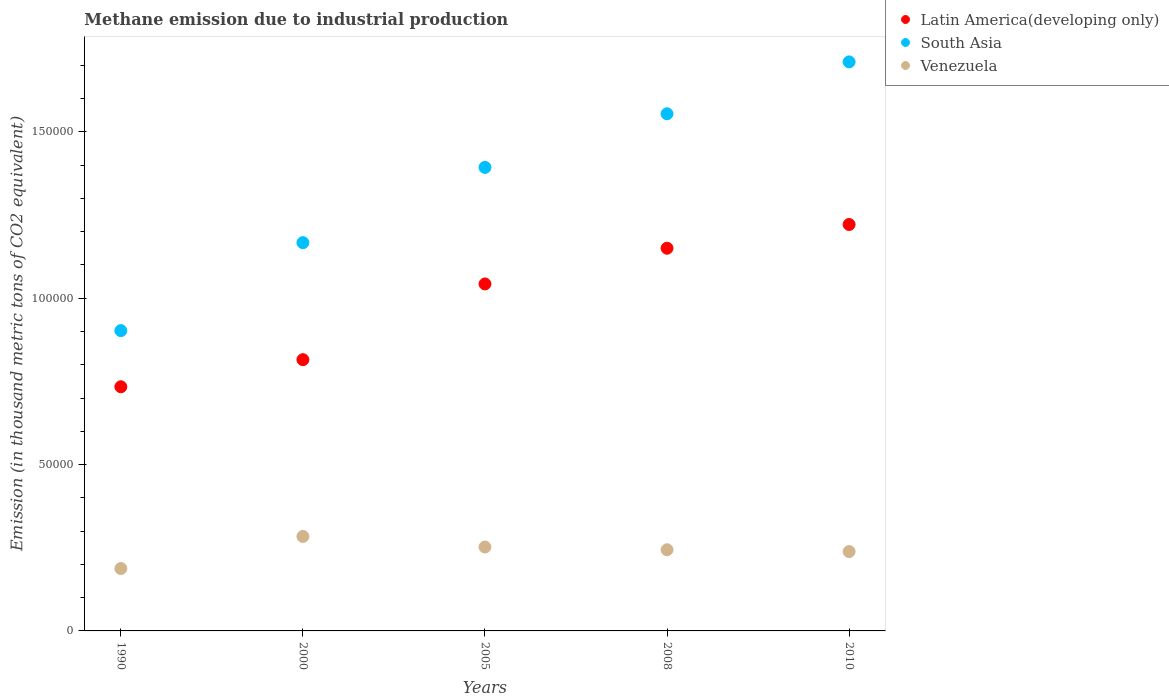How many different coloured dotlines are there?
Your answer should be very brief. 3. Is the number of dotlines equal to the number of legend labels?
Make the answer very short. Yes. What is the amount of methane emitted in Latin America(developing only) in 2000?
Keep it short and to the point. 8.15e+04. Across all years, what is the maximum amount of methane emitted in South Asia?
Provide a succinct answer. 1.71e+05. Across all years, what is the minimum amount of methane emitted in South Asia?
Your answer should be compact. 9.03e+04. In which year was the amount of methane emitted in Latin America(developing only) maximum?
Offer a very short reply. 2010. What is the total amount of methane emitted in Venezuela in the graph?
Keep it short and to the point. 1.21e+05. What is the difference between the amount of methane emitted in Latin America(developing only) in 2000 and that in 2008?
Your answer should be compact. -3.35e+04. What is the difference between the amount of methane emitted in Venezuela in 2010 and the amount of methane emitted in Latin America(developing only) in 2008?
Ensure brevity in your answer.  -9.12e+04. What is the average amount of methane emitted in Latin America(developing only) per year?
Provide a short and direct response. 9.93e+04. In the year 2008, what is the difference between the amount of methane emitted in South Asia and amount of methane emitted in Latin America(developing only)?
Offer a very short reply. 4.04e+04. What is the ratio of the amount of methane emitted in South Asia in 2005 to that in 2008?
Offer a very short reply. 0.9. Is the amount of methane emitted in Venezuela in 1990 less than that in 2005?
Offer a very short reply. Yes. What is the difference between the highest and the second highest amount of methane emitted in Latin America(developing only)?
Keep it short and to the point. 7129.8. What is the difference between the highest and the lowest amount of methane emitted in Venezuela?
Make the answer very short. 9645.4. Is it the case that in every year, the sum of the amount of methane emitted in Venezuela and amount of methane emitted in South Asia  is greater than the amount of methane emitted in Latin America(developing only)?
Give a very brief answer. Yes. Does the amount of methane emitted in Latin America(developing only) monotonically increase over the years?
Your response must be concise. Yes. Is the amount of methane emitted in South Asia strictly greater than the amount of methane emitted in Latin America(developing only) over the years?
Offer a very short reply. Yes. How many years are there in the graph?
Your answer should be very brief. 5. What is the difference between two consecutive major ticks on the Y-axis?
Provide a short and direct response. 5.00e+04. Are the values on the major ticks of Y-axis written in scientific E-notation?
Offer a very short reply. No. Does the graph contain any zero values?
Your answer should be very brief. No. Does the graph contain grids?
Keep it short and to the point. No. Where does the legend appear in the graph?
Provide a succinct answer. Top right. How many legend labels are there?
Give a very brief answer. 3. How are the legend labels stacked?
Give a very brief answer. Vertical. What is the title of the graph?
Provide a short and direct response. Methane emission due to industrial production. Does "India" appear as one of the legend labels in the graph?
Give a very brief answer. No. What is the label or title of the X-axis?
Provide a succinct answer. Years. What is the label or title of the Y-axis?
Offer a very short reply. Emission (in thousand metric tons of CO2 equivalent). What is the Emission (in thousand metric tons of CO2 equivalent) of Latin America(developing only) in 1990?
Your answer should be very brief. 7.34e+04. What is the Emission (in thousand metric tons of CO2 equivalent) of South Asia in 1990?
Make the answer very short. 9.03e+04. What is the Emission (in thousand metric tons of CO2 equivalent) in Venezuela in 1990?
Offer a very short reply. 1.88e+04. What is the Emission (in thousand metric tons of CO2 equivalent) of Latin America(developing only) in 2000?
Make the answer very short. 8.15e+04. What is the Emission (in thousand metric tons of CO2 equivalent) of South Asia in 2000?
Your answer should be compact. 1.17e+05. What is the Emission (in thousand metric tons of CO2 equivalent) of Venezuela in 2000?
Provide a short and direct response. 2.84e+04. What is the Emission (in thousand metric tons of CO2 equivalent) of Latin America(developing only) in 2005?
Ensure brevity in your answer.  1.04e+05. What is the Emission (in thousand metric tons of CO2 equivalent) in South Asia in 2005?
Give a very brief answer. 1.39e+05. What is the Emission (in thousand metric tons of CO2 equivalent) in Venezuela in 2005?
Provide a short and direct response. 2.52e+04. What is the Emission (in thousand metric tons of CO2 equivalent) in Latin America(developing only) in 2008?
Your answer should be compact. 1.15e+05. What is the Emission (in thousand metric tons of CO2 equivalent) of South Asia in 2008?
Provide a succinct answer. 1.55e+05. What is the Emission (in thousand metric tons of CO2 equivalent) of Venezuela in 2008?
Offer a very short reply. 2.44e+04. What is the Emission (in thousand metric tons of CO2 equivalent) in Latin America(developing only) in 2010?
Give a very brief answer. 1.22e+05. What is the Emission (in thousand metric tons of CO2 equivalent) of South Asia in 2010?
Offer a very short reply. 1.71e+05. What is the Emission (in thousand metric tons of CO2 equivalent) in Venezuela in 2010?
Your response must be concise. 2.39e+04. Across all years, what is the maximum Emission (in thousand metric tons of CO2 equivalent) of Latin America(developing only)?
Offer a very short reply. 1.22e+05. Across all years, what is the maximum Emission (in thousand metric tons of CO2 equivalent) of South Asia?
Your answer should be very brief. 1.71e+05. Across all years, what is the maximum Emission (in thousand metric tons of CO2 equivalent) in Venezuela?
Offer a very short reply. 2.84e+04. Across all years, what is the minimum Emission (in thousand metric tons of CO2 equivalent) of Latin America(developing only)?
Provide a short and direct response. 7.34e+04. Across all years, what is the minimum Emission (in thousand metric tons of CO2 equivalent) of South Asia?
Your answer should be very brief. 9.03e+04. Across all years, what is the minimum Emission (in thousand metric tons of CO2 equivalent) of Venezuela?
Make the answer very short. 1.88e+04. What is the total Emission (in thousand metric tons of CO2 equivalent) in Latin America(developing only) in the graph?
Give a very brief answer. 4.96e+05. What is the total Emission (in thousand metric tons of CO2 equivalent) of South Asia in the graph?
Your response must be concise. 6.73e+05. What is the total Emission (in thousand metric tons of CO2 equivalent) in Venezuela in the graph?
Provide a short and direct response. 1.21e+05. What is the difference between the Emission (in thousand metric tons of CO2 equivalent) in Latin America(developing only) in 1990 and that in 2000?
Offer a terse response. -8151.9. What is the difference between the Emission (in thousand metric tons of CO2 equivalent) of South Asia in 1990 and that in 2000?
Your answer should be very brief. -2.64e+04. What is the difference between the Emission (in thousand metric tons of CO2 equivalent) in Venezuela in 1990 and that in 2000?
Provide a succinct answer. -9645.4. What is the difference between the Emission (in thousand metric tons of CO2 equivalent) in Latin America(developing only) in 1990 and that in 2005?
Ensure brevity in your answer.  -3.09e+04. What is the difference between the Emission (in thousand metric tons of CO2 equivalent) in South Asia in 1990 and that in 2005?
Make the answer very short. -4.91e+04. What is the difference between the Emission (in thousand metric tons of CO2 equivalent) in Venezuela in 1990 and that in 2005?
Keep it short and to the point. -6462.5. What is the difference between the Emission (in thousand metric tons of CO2 equivalent) in Latin America(developing only) in 1990 and that in 2008?
Offer a terse response. -4.16e+04. What is the difference between the Emission (in thousand metric tons of CO2 equivalent) of South Asia in 1990 and that in 2008?
Your answer should be very brief. -6.52e+04. What is the difference between the Emission (in thousand metric tons of CO2 equivalent) of Venezuela in 1990 and that in 2008?
Give a very brief answer. -5639.8. What is the difference between the Emission (in thousand metric tons of CO2 equivalent) in Latin America(developing only) in 1990 and that in 2010?
Offer a terse response. -4.88e+04. What is the difference between the Emission (in thousand metric tons of CO2 equivalent) of South Asia in 1990 and that in 2010?
Ensure brevity in your answer.  -8.08e+04. What is the difference between the Emission (in thousand metric tons of CO2 equivalent) in Venezuela in 1990 and that in 2010?
Offer a very short reply. -5098.4. What is the difference between the Emission (in thousand metric tons of CO2 equivalent) of Latin America(developing only) in 2000 and that in 2005?
Ensure brevity in your answer.  -2.28e+04. What is the difference between the Emission (in thousand metric tons of CO2 equivalent) in South Asia in 2000 and that in 2005?
Offer a very short reply. -2.26e+04. What is the difference between the Emission (in thousand metric tons of CO2 equivalent) in Venezuela in 2000 and that in 2005?
Provide a succinct answer. 3182.9. What is the difference between the Emission (in thousand metric tons of CO2 equivalent) in Latin America(developing only) in 2000 and that in 2008?
Your response must be concise. -3.35e+04. What is the difference between the Emission (in thousand metric tons of CO2 equivalent) of South Asia in 2000 and that in 2008?
Keep it short and to the point. -3.87e+04. What is the difference between the Emission (in thousand metric tons of CO2 equivalent) of Venezuela in 2000 and that in 2008?
Provide a succinct answer. 4005.6. What is the difference between the Emission (in thousand metric tons of CO2 equivalent) of Latin America(developing only) in 2000 and that in 2010?
Your answer should be very brief. -4.06e+04. What is the difference between the Emission (in thousand metric tons of CO2 equivalent) of South Asia in 2000 and that in 2010?
Your response must be concise. -5.43e+04. What is the difference between the Emission (in thousand metric tons of CO2 equivalent) of Venezuela in 2000 and that in 2010?
Provide a short and direct response. 4547. What is the difference between the Emission (in thousand metric tons of CO2 equivalent) of Latin America(developing only) in 2005 and that in 2008?
Keep it short and to the point. -1.07e+04. What is the difference between the Emission (in thousand metric tons of CO2 equivalent) of South Asia in 2005 and that in 2008?
Your answer should be very brief. -1.61e+04. What is the difference between the Emission (in thousand metric tons of CO2 equivalent) in Venezuela in 2005 and that in 2008?
Ensure brevity in your answer.  822.7. What is the difference between the Emission (in thousand metric tons of CO2 equivalent) in Latin America(developing only) in 2005 and that in 2010?
Provide a short and direct response. -1.79e+04. What is the difference between the Emission (in thousand metric tons of CO2 equivalent) in South Asia in 2005 and that in 2010?
Your response must be concise. -3.17e+04. What is the difference between the Emission (in thousand metric tons of CO2 equivalent) of Venezuela in 2005 and that in 2010?
Make the answer very short. 1364.1. What is the difference between the Emission (in thousand metric tons of CO2 equivalent) of Latin America(developing only) in 2008 and that in 2010?
Provide a succinct answer. -7129.8. What is the difference between the Emission (in thousand metric tons of CO2 equivalent) in South Asia in 2008 and that in 2010?
Provide a short and direct response. -1.56e+04. What is the difference between the Emission (in thousand metric tons of CO2 equivalent) in Venezuela in 2008 and that in 2010?
Offer a terse response. 541.4. What is the difference between the Emission (in thousand metric tons of CO2 equivalent) in Latin America(developing only) in 1990 and the Emission (in thousand metric tons of CO2 equivalent) in South Asia in 2000?
Your answer should be compact. -4.33e+04. What is the difference between the Emission (in thousand metric tons of CO2 equivalent) in Latin America(developing only) in 1990 and the Emission (in thousand metric tons of CO2 equivalent) in Venezuela in 2000?
Make the answer very short. 4.50e+04. What is the difference between the Emission (in thousand metric tons of CO2 equivalent) in South Asia in 1990 and the Emission (in thousand metric tons of CO2 equivalent) in Venezuela in 2000?
Offer a terse response. 6.19e+04. What is the difference between the Emission (in thousand metric tons of CO2 equivalent) of Latin America(developing only) in 1990 and the Emission (in thousand metric tons of CO2 equivalent) of South Asia in 2005?
Keep it short and to the point. -6.59e+04. What is the difference between the Emission (in thousand metric tons of CO2 equivalent) in Latin America(developing only) in 1990 and the Emission (in thousand metric tons of CO2 equivalent) in Venezuela in 2005?
Your answer should be compact. 4.82e+04. What is the difference between the Emission (in thousand metric tons of CO2 equivalent) of South Asia in 1990 and the Emission (in thousand metric tons of CO2 equivalent) of Venezuela in 2005?
Provide a short and direct response. 6.50e+04. What is the difference between the Emission (in thousand metric tons of CO2 equivalent) of Latin America(developing only) in 1990 and the Emission (in thousand metric tons of CO2 equivalent) of South Asia in 2008?
Give a very brief answer. -8.20e+04. What is the difference between the Emission (in thousand metric tons of CO2 equivalent) in Latin America(developing only) in 1990 and the Emission (in thousand metric tons of CO2 equivalent) in Venezuela in 2008?
Offer a terse response. 4.90e+04. What is the difference between the Emission (in thousand metric tons of CO2 equivalent) in South Asia in 1990 and the Emission (in thousand metric tons of CO2 equivalent) in Venezuela in 2008?
Provide a short and direct response. 6.59e+04. What is the difference between the Emission (in thousand metric tons of CO2 equivalent) in Latin America(developing only) in 1990 and the Emission (in thousand metric tons of CO2 equivalent) in South Asia in 2010?
Make the answer very short. -9.76e+04. What is the difference between the Emission (in thousand metric tons of CO2 equivalent) in Latin America(developing only) in 1990 and the Emission (in thousand metric tons of CO2 equivalent) in Venezuela in 2010?
Offer a terse response. 4.95e+04. What is the difference between the Emission (in thousand metric tons of CO2 equivalent) of South Asia in 1990 and the Emission (in thousand metric tons of CO2 equivalent) of Venezuela in 2010?
Your response must be concise. 6.64e+04. What is the difference between the Emission (in thousand metric tons of CO2 equivalent) of Latin America(developing only) in 2000 and the Emission (in thousand metric tons of CO2 equivalent) of South Asia in 2005?
Offer a terse response. -5.78e+04. What is the difference between the Emission (in thousand metric tons of CO2 equivalent) of Latin America(developing only) in 2000 and the Emission (in thousand metric tons of CO2 equivalent) of Venezuela in 2005?
Make the answer very short. 5.63e+04. What is the difference between the Emission (in thousand metric tons of CO2 equivalent) in South Asia in 2000 and the Emission (in thousand metric tons of CO2 equivalent) in Venezuela in 2005?
Offer a terse response. 9.15e+04. What is the difference between the Emission (in thousand metric tons of CO2 equivalent) of Latin America(developing only) in 2000 and the Emission (in thousand metric tons of CO2 equivalent) of South Asia in 2008?
Keep it short and to the point. -7.39e+04. What is the difference between the Emission (in thousand metric tons of CO2 equivalent) in Latin America(developing only) in 2000 and the Emission (in thousand metric tons of CO2 equivalent) in Venezuela in 2008?
Offer a terse response. 5.71e+04. What is the difference between the Emission (in thousand metric tons of CO2 equivalent) in South Asia in 2000 and the Emission (in thousand metric tons of CO2 equivalent) in Venezuela in 2008?
Provide a succinct answer. 9.23e+04. What is the difference between the Emission (in thousand metric tons of CO2 equivalent) in Latin America(developing only) in 2000 and the Emission (in thousand metric tons of CO2 equivalent) in South Asia in 2010?
Keep it short and to the point. -8.95e+04. What is the difference between the Emission (in thousand metric tons of CO2 equivalent) in Latin America(developing only) in 2000 and the Emission (in thousand metric tons of CO2 equivalent) in Venezuela in 2010?
Your answer should be very brief. 5.77e+04. What is the difference between the Emission (in thousand metric tons of CO2 equivalent) of South Asia in 2000 and the Emission (in thousand metric tons of CO2 equivalent) of Venezuela in 2010?
Provide a short and direct response. 9.28e+04. What is the difference between the Emission (in thousand metric tons of CO2 equivalent) in Latin America(developing only) in 2005 and the Emission (in thousand metric tons of CO2 equivalent) in South Asia in 2008?
Your answer should be very brief. -5.11e+04. What is the difference between the Emission (in thousand metric tons of CO2 equivalent) of Latin America(developing only) in 2005 and the Emission (in thousand metric tons of CO2 equivalent) of Venezuela in 2008?
Offer a very short reply. 7.99e+04. What is the difference between the Emission (in thousand metric tons of CO2 equivalent) in South Asia in 2005 and the Emission (in thousand metric tons of CO2 equivalent) in Venezuela in 2008?
Give a very brief answer. 1.15e+05. What is the difference between the Emission (in thousand metric tons of CO2 equivalent) in Latin America(developing only) in 2005 and the Emission (in thousand metric tons of CO2 equivalent) in South Asia in 2010?
Provide a succinct answer. -6.67e+04. What is the difference between the Emission (in thousand metric tons of CO2 equivalent) of Latin America(developing only) in 2005 and the Emission (in thousand metric tons of CO2 equivalent) of Venezuela in 2010?
Give a very brief answer. 8.04e+04. What is the difference between the Emission (in thousand metric tons of CO2 equivalent) in South Asia in 2005 and the Emission (in thousand metric tons of CO2 equivalent) in Venezuela in 2010?
Ensure brevity in your answer.  1.15e+05. What is the difference between the Emission (in thousand metric tons of CO2 equivalent) in Latin America(developing only) in 2008 and the Emission (in thousand metric tons of CO2 equivalent) in South Asia in 2010?
Ensure brevity in your answer.  -5.60e+04. What is the difference between the Emission (in thousand metric tons of CO2 equivalent) of Latin America(developing only) in 2008 and the Emission (in thousand metric tons of CO2 equivalent) of Venezuela in 2010?
Your response must be concise. 9.12e+04. What is the difference between the Emission (in thousand metric tons of CO2 equivalent) in South Asia in 2008 and the Emission (in thousand metric tons of CO2 equivalent) in Venezuela in 2010?
Offer a very short reply. 1.32e+05. What is the average Emission (in thousand metric tons of CO2 equivalent) of Latin America(developing only) per year?
Your answer should be compact. 9.93e+04. What is the average Emission (in thousand metric tons of CO2 equivalent) of South Asia per year?
Provide a succinct answer. 1.35e+05. What is the average Emission (in thousand metric tons of CO2 equivalent) of Venezuela per year?
Offer a terse response. 2.41e+04. In the year 1990, what is the difference between the Emission (in thousand metric tons of CO2 equivalent) of Latin America(developing only) and Emission (in thousand metric tons of CO2 equivalent) of South Asia?
Make the answer very short. -1.69e+04. In the year 1990, what is the difference between the Emission (in thousand metric tons of CO2 equivalent) of Latin America(developing only) and Emission (in thousand metric tons of CO2 equivalent) of Venezuela?
Your answer should be very brief. 5.46e+04. In the year 1990, what is the difference between the Emission (in thousand metric tons of CO2 equivalent) of South Asia and Emission (in thousand metric tons of CO2 equivalent) of Venezuela?
Offer a terse response. 7.15e+04. In the year 2000, what is the difference between the Emission (in thousand metric tons of CO2 equivalent) in Latin America(developing only) and Emission (in thousand metric tons of CO2 equivalent) in South Asia?
Give a very brief answer. -3.52e+04. In the year 2000, what is the difference between the Emission (in thousand metric tons of CO2 equivalent) in Latin America(developing only) and Emission (in thousand metric tons of CO2 equivalent) in Venezuela?
Offer a terse response. 5.31e+04. In the year 2000, what is the difference between the Emission (in thousand metric tons of CO2 equivalent) of South Asia and Emission (in thousand metric tons of CO2 equivalent) of Venezuela?
Ensure brevity in your answer.  8.83e+04. In the year 2005, what is the difference between the Emission (in thousand metric tons of CO2 equivalent) in Latin America(developing only) and Emission (in thousand metric tons of CO2 equivalent) in South Asia?
Your response must be concise. -3.50e+04. In the year 2005, what is the difference between the Emission (in thousand metric tons of CO2 equivalent) in Latin America(developing only) and Emission (in thousand metric tons of CO2 equivalent) in Venezuela?
Your answer should be compact. 7.91e+04. In the year 2005, what is the difference between the Emission (in thousand metric tons of CO2 equivalent) in South Asia and Emission (in thousand metric tons of CO2 equivalent) in Venezuela?
Your response must be concise. 1.14e+05. In the year 2008, what is the difference between the Emission (in thousand metric tons of CO2 equivalent) in Latin America(developing only) and Emission (in thousand metric tons of CO2 equivalent) in South Asia?
Provide a short and direct response. -4.04e+04. In the year 2008, what is the difference between the Emission (in thousand metric tons of CO2 equivalent) in Latin America(developing only) and Emission (in thousand metric tons of CO2 equivalent) in Venezuela?
Make the answer very short. 9.06e+04. In the year 2008, what is the difference between the Emission (in thousand metric tons of CO2 equivalent) of South Asia and Emission (in thousand metric tons of CO2 equivalent) of Venezuela?
Keep it short and to the point. 1.31e+05. In the year 2010, what is the difference between the Emission (in thousand metric tons of CO2 equivalent) in Latin America(developing only) and Emission (in thousand metric tons of CO2 equivalent) in South Asia?
Ensure brevity in your answer.  -4.89e+04. In the year 2010, what is the difference between the Emission (in thousand metric tons of CO2 equivalent) of Latin America(developing only) and Emission (in thousand metric tons of CO2 equivalent) of Venezuela?
Provide a short and direct response. 9.83e+04. In the year 2010, what is the difference between the Emission (in thousand metric tons of CO2 equivalent) in South Asia and Emission (in thousand metric tons of CO2 equivalent) in Venezuela?
Your response must be concise. 1.47e+05. What is the ratio of the Emission (in thousand metric tons of CO2 equivalent) in Latin America(developing only) in 1990 to that in 2000?
Provide a succinct answer. 0.9. What is the ratio of the Emission (in thousand metric tons of CO2 equivalent) in South Asia in 1990 to that in 2000?
Your response must be concise. 0.77. What is the ratio of the Emission (in thousand metric tons of CO2 equivalent) in Venezuela in 1990 to that in 2000?
Offer a very short reply. 0.66. What is the ratio of the Emission (in thousand metric tons of CO2 equivalent) of Latin America(developing only) in 1990 to that in 2005?
Provide a short and direct response. 0.7. What is the ratio of the Emission (in thousand metric tons of CO2 equivalent) in South Asia in 1990 to that in 2005?
Provide a short and direct response. 0.65. What is the ratio of the Emission (in thousand metric tons of CO2 equivalent) in Venezuela in 1990 to that in 2005?
Your response must be concise. 0.74. What is the ratio of the Emission (in thousand metric tons of CO2 equivalent) of Latin America(developing only) in 1990 to that in 2008?
Keep it short and to the point. 0.64. What is the ratio of the Emission (in thousand metric tons of CO2 equivalent) in South Asia in 1990 to that in 2008?
Your answer should be very brief. 0.58. What is the ratio of the Emission (in thousand metric tons of CO2 equivalent) of Venezuela in 1990 to that in 2008?
Your answer should be very brief. 0.77. What is the ratio of the Emission (in thousand metric tons of CO2 equivalent) in Latin America(developing only) in 1990 to that in 2010?
Offer a terse response. 0.6. What is the ratio of the Emission (in thousand metric tons of CO2 equivalent) of South Asia in 1990 to that in 2010?
Your answer should be very brief. 0.53. What is the ratio of the Emission (in thousand metric tons of CO2 equivalent) in Venezuela in 1990 to that in 2010?
Give a very brief answer. 0.79. What is the ratio of the Emission (in thousand metric tons of CO2 equivalent) of Latin America(developing only) in 2000 to that in 2005?
Keep it short and to the point. 0.78. What is the ratio of the Emission (in thousand metric tons of CO2 equivalent) in South Asia in 2000 to that in 2005?
Provide a succinct answer. 0.84. What is the ratio of the Emission (in thousand metric tons of CO2 equivalent) in Venezuela in 2000 to that in 2005?
Give a very brief answer. 1.13. What is the ratio of the Emission (in thousand metric tons of CO2 equivalent) of Latin America(developing only) in 2000 to that in 2008?
Your answer should be compact. 0.71. What is the ratio of the Emission (in thousand metric tons of CO2 equivalent) in South Asia in 2000 to that in 2008?
Keep it short and to the point. 0.75. What is the ratio of the Emission (in thousand metric tons of CO2 equivalent) in Venezuela in 2000 to that in 2008?
Give a very brief answer. 1.16. What is the ratio of the Emission (in thousand metric tons of CO2 equivalent) of Latin America(developing only) in 2000 to that in 2010?
Your response must be concise. 0.67. What is the ratio of the Emission (in thousand metric tons of CO2 equivalent) of South Asia in 2000 to that in 2010?
Your response must be concise. 0.68. What is the ratio of the Emission (in thousand metric tons of CO2 equivalent) of Venezuela in 2000 to that in 2010?
Make the answer very short. 1.19. What is the ratio of the Emission (in thousand metric tons of CO2 equivalent) in Latin America(developing only) in 2005 to that in 2008?
Your answer should be compact. 0.91. What is the ratio of the Emission (in thousand metric tons of CO2 equivalent) of South Asia in 2005 to that in 2008?
Offer a very short reply. 0.9. What is the ratio of the Emission (in thousand metric tons of CO2 equivalent) in Venezuela in 2005 to that in 2008?
Ensure brevity in your answer.  1.03. What is the ratio of the Emission (in thousand metric tons of CO2 equivalent) of Latin America(developing only) in 2005 to that in 2010?
Your answer should be very brief. 0.85. What is the ratio of the Emission (in thousand metric tons of CO2 equivalent) of South Asia in 2005 to that in 2010?
Offer a very short reply. 0.81. What is the ratio of the Emission (in thousand metric tons of CO2 equivalent) in Venezuela in 2005 to that in 2010?
Offer a very short reply. 1.06. What is the ratio of the Emission (in thousand metric tons of CO2 equivalent) of Latin America(developing only) in 2008 to that in 2010?
Give a very brief answer. 0.94. What is the ratio of the Emission (in thousand metric tons of CO2 equivalent) in South Asia in 2008 to that in 2010?
Give a very brief answer. 0.91. What is the ratio of the Emission (in thousand metric tons of CO2 equivalent) of Venezuela in 2008 to that in 2010?
Provide a short and direct response. 1.02. What is the difference between the highest and the second highest Emission (in thousand metric tons of CO2 equivalent) of Latin America(developing only)?
Your answer should be compact. 7129.8. What is the difference between the highest and the second highest Emission (in thousand metric tons of CO2 equivalent) in South Asia?
Offer a very short reply. 1.56e+04. What is the difference between the highest and the second highest Emission (in thousand metric tons of CO2 equivalent) in Venezuela?
Your response must be concise. 3182.9. What is the difference between the highest and the lowest Emission (in thousand metric tons of CO2 equivalent) of Latin America(developing only)?
Make the answer very short. 4.88e+04. What is the difference between the highest and the lowest Emission (in thousand metric tons of CO2 equivalent) of South Asia?
Your answer should be very brief. 8.08e+04. What is the difference between the highest and the lowest Emission (in thousand metric tons of CO2 equivalent) of Venezuela?
Your answer should be very brief. 9645.4. 